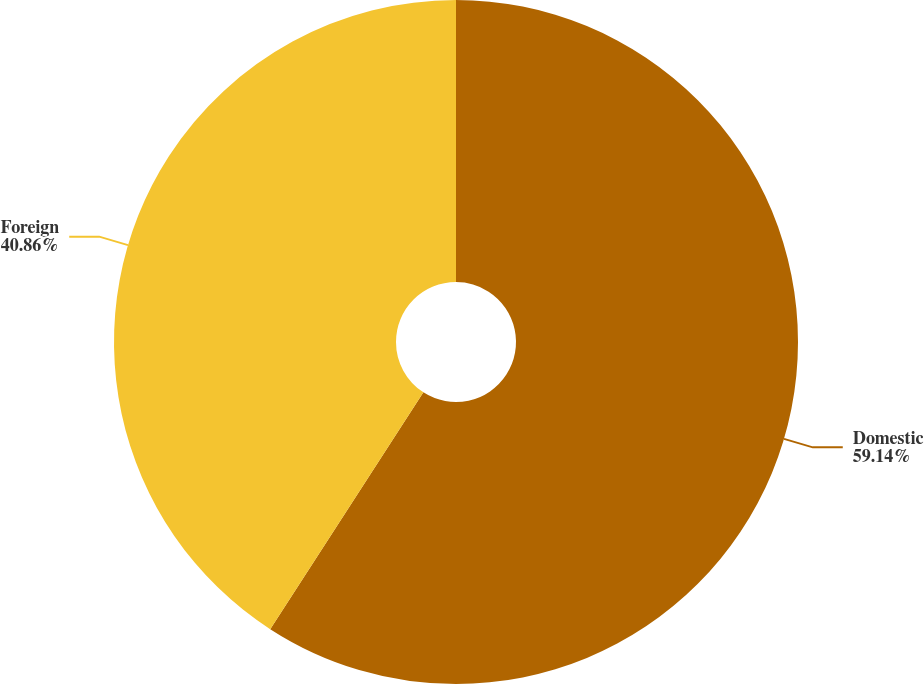Convert chart to OTSL. <chart><loc_0><loc_0><loc_500><loc_500><pie_chart><fcel>Domestic<fcel>Foreign<nl><fcel>59.14%<fcel>40.86%<nl></chart> 